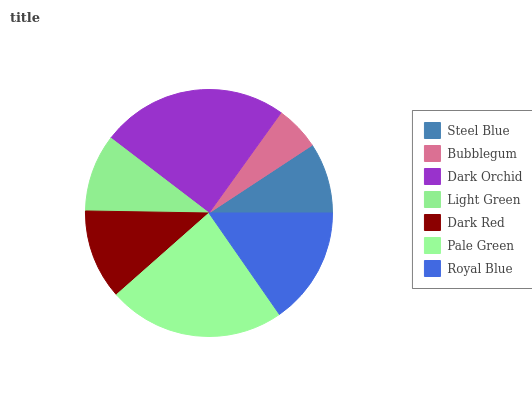Is Bubblegum the minimum?
Answer yes or no. Yes. Is Dark Orchid the maximum?
Answer yes or no. Yes. Is Dark Orchid the minimum?
Answer yes or no. No. Is Bubblegum the maximum?
Answer yes or no. No. Is Dark Orchid greater than Bubblegum?
Answer yes or no. Yes. Is Bubblegum less than Dark Orchid?
Answer yes or no. Yes. Is Bubblegum greater than Dark Orchid?
Answer yes or no. No. Is Dark Orchid less than Bubblegum?
Answer yes or no. No. Is Dark Red the high median?
Answer yes or no. Yes. Is Dark Red the low median?
Answer yes or no. Yes. Is Royal Blue the high median?
Answer yes or no. No. Is Royal Blue the low median?
Answer yes or no. No. 